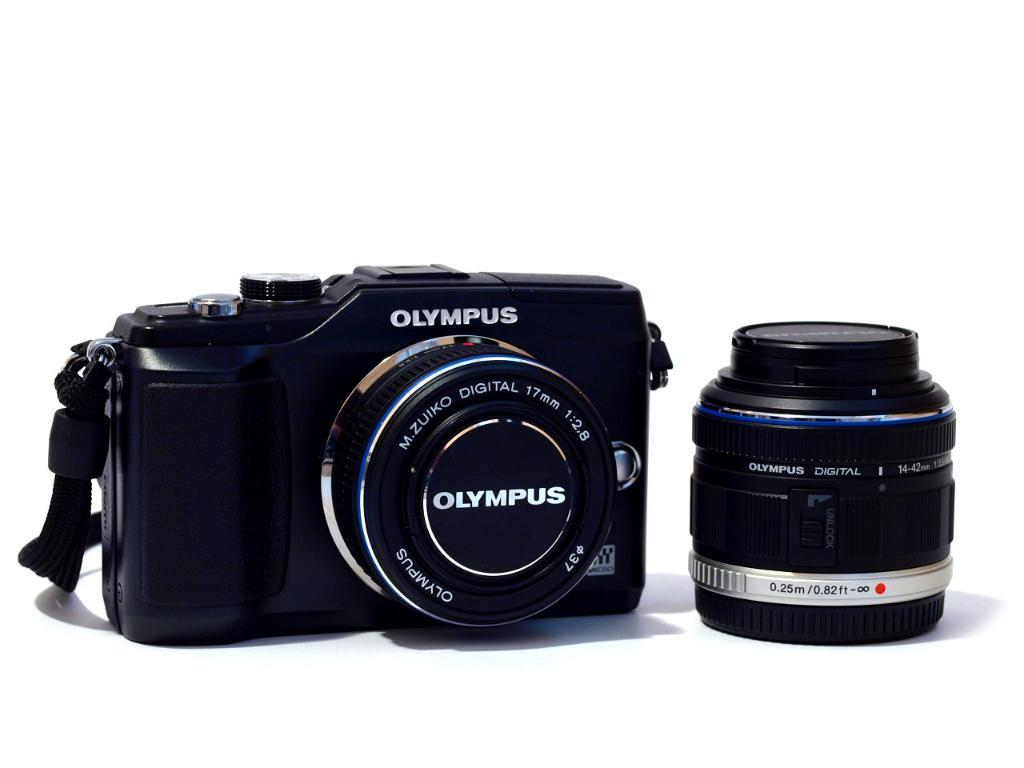<image>
Summarize the visual content of the image. A black olympus branded digital camera with its lens sitting next to it. 